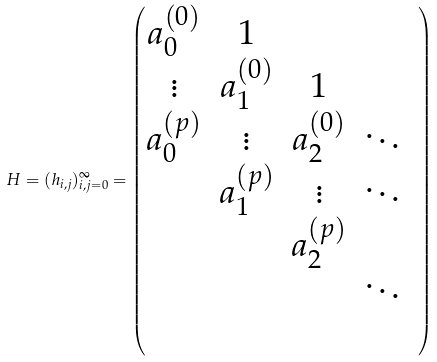<formula> <loc_0><loc_0><loc_500><loc_500>H = ( h _ { i , j } ) _ { i , j = 0 } ^ { \infty } = \begin{pmatrix} a _ { 0 } ^ { ( 0 ) } & 1 & & & \\ \vdots & a _ { 1 } ^ { ( 0 ) } & 1 & \\ a _ { 0 } ^ { ( p ) } & \vdots & a _ { 2 } ^ { ( 0 ) } & \ddots \\ & a _ { 1 } ^ { ( p ) } & \vdots & \ddots \\ & & a _ { 2 } ^ { ( p ) } & \\ & & & \ddots \\ & \end{pmatrix}</formula> 